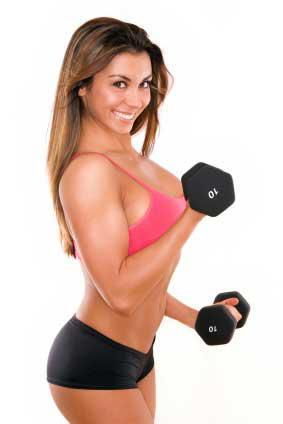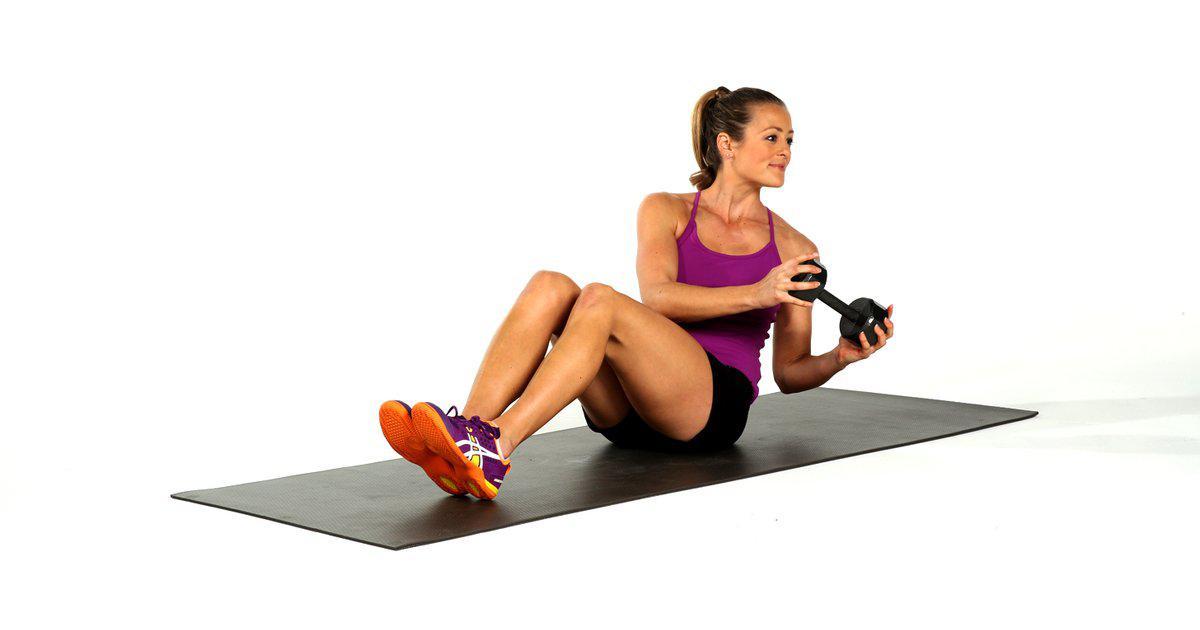The first image is the image on the left, the second image is the image on the right. For the images displayed, is the sentence "In the right image a woman is standing but kneeling towards the ground with one knee close to the floor." factually correct? Answer yes or no. No. 